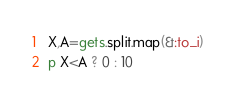Convert code to text. <code><loc_0><loc_0><loc_500><loc_500><_Ruby_>X,A=gets.split.map(&:to_i)
p X<A ? 0 : 10</code> 